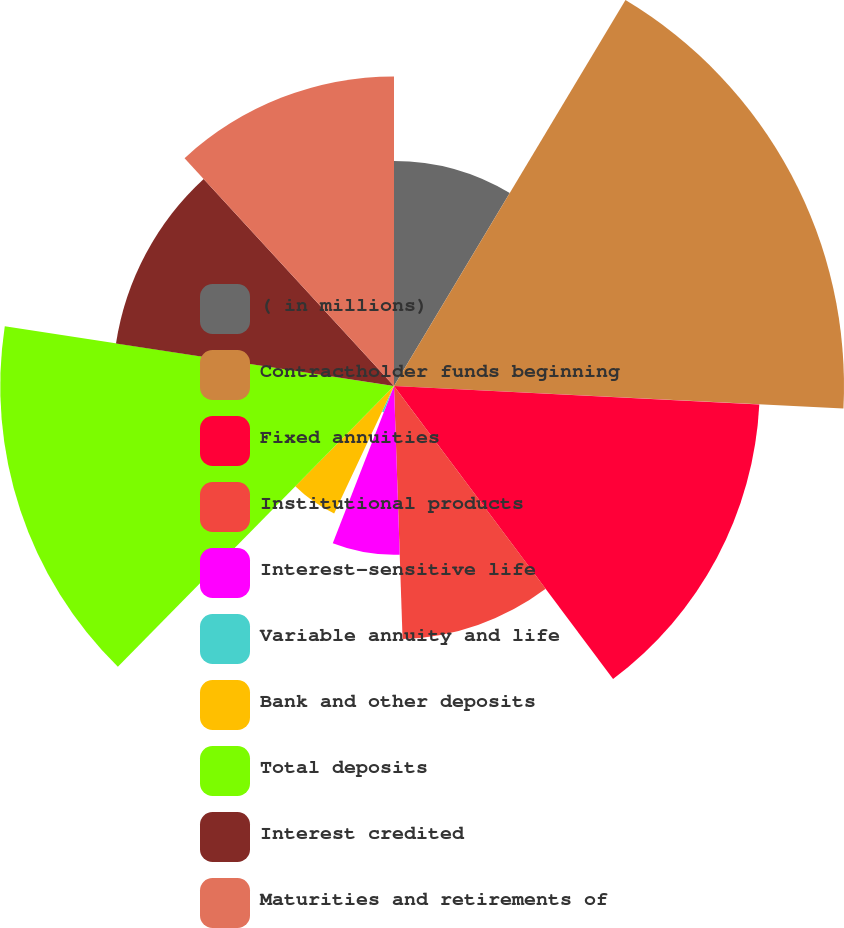Convert chart to OTSL. <chart><loc_0><loc_0><loc_500><loc_500><pie_chart><fcel>( in millions)<fcel>Contractholder funds beginning<fcel>Fixed annuities<fcel>Institutional products<fcel>Interest-sensitive life<fcel>Variable annuity and life<fcel>Bank and other deposits<fcel>Total deposits<fcel>Interest credited<fcel>Maturities and retirements of<nl><fcel>8.6%<fcel>17.2%<fcel>13.98%<fcel>9.68%<fcel>6.45%<fcel>1.08%<fcel>5.38%<fcel>15.05%<fcel>10.75%<fcel>11.83%<nl></chart> 